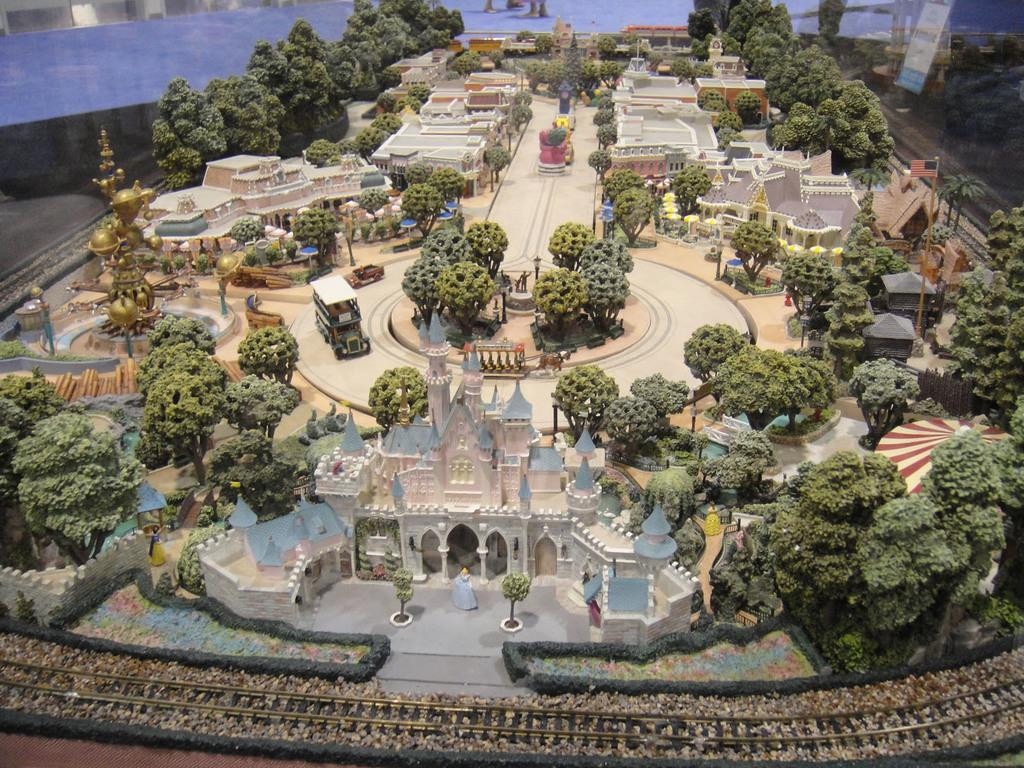What type of building is the main subject of the image? There is a palace in the image. Who is present in the image along with the palace? There is a king and a queen in the image. What type of natural elements can be seen in the image? There are trees in the image. What type of man-made structures are visible in the image? There are buildings in the image. What type of path or route is visible in the image? There is a track in the image. What other objects can be seen in the image? There are other objects in the image. What is the mother of the king doing in the image? There is no mention of a mother in the image, so it cannot be determined what she might be doing. 